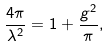Convert formula to latex. <formula><loc_0><loc_0><loc_500><loc_500>\frac { 4 \pi } { \lambda ^ { 2 } } = 1 + \frac { g ^ { 2 } } { \pi } ,</formula> 